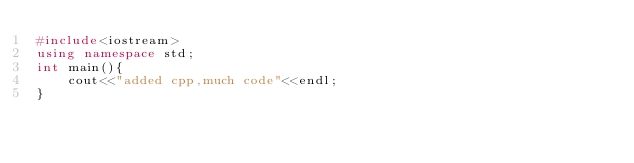Convert code to text. <code><loc_0><loc_0><loc_500><loc_500><_C++_>#include<iostream>
using namespace std;
int main(){
    cout<<"added cpp,much code"<<endl;
}</code> 